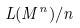Convert formula to latex. <formula><loc_0><loc_0><loc_500><loc_500>L ( M ^ { n } ) / n</formula> 